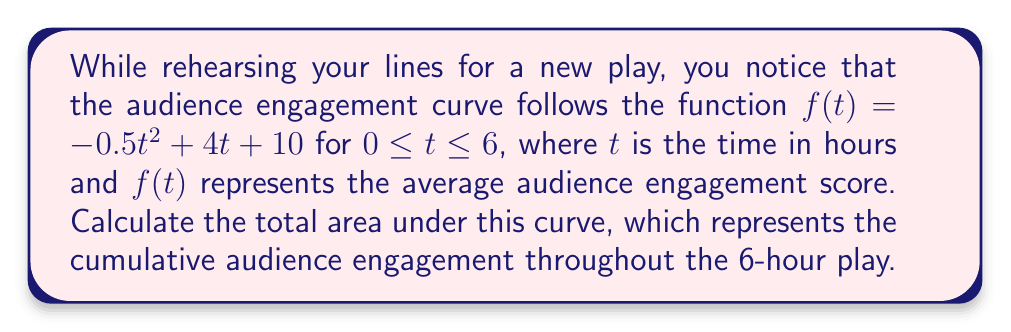Could you help me with this problem? To find the area under the curve, we need to integrate the function $f(t)$ from $t=0$ to $t=6$. Let's follow these steps:

1) The integral we need to evaluate is:

   $$\int_0^6 (-0.5t^2 + 4t + 10) dt$$

2) Integrate each term separately:
   
   $$\int -0.5t^2 dt = -\frac{1}{6}t^3$$
   $$\int 4t dt = 2t^2$$
   $$\int 10 dt = 10t$$

3) Combine these terms:

   $$\int (-0.5t^2 + 4t + 10) dt = -\frac{1}{6}t^3 + 2t^2 + 10t + C$$

4) Now, we need to evaluate this at the limits $t=0$ and $t=6$:

   $$[-\frac{1}{6}t^3 + 2t^2 + 10t]_0^6$$

5) Substitute $t=6$:

   $$-\frac{1}{6}(6^3) + 2(6^2) + 10(6) = -36 + 72 + 60 = 96$$

6) Substitute $t=0$:

   $$-\frac{1}{6}(0^3) + 2(0^2) + 10(0) = 0$$

7) Subtract the result at $t=0$ from the result at $t=6$:

   $$96 - 0 = 96$$

Therefore, the total area under the curve is 96 engagement-hours.
Answer: 96 engagement-hours 